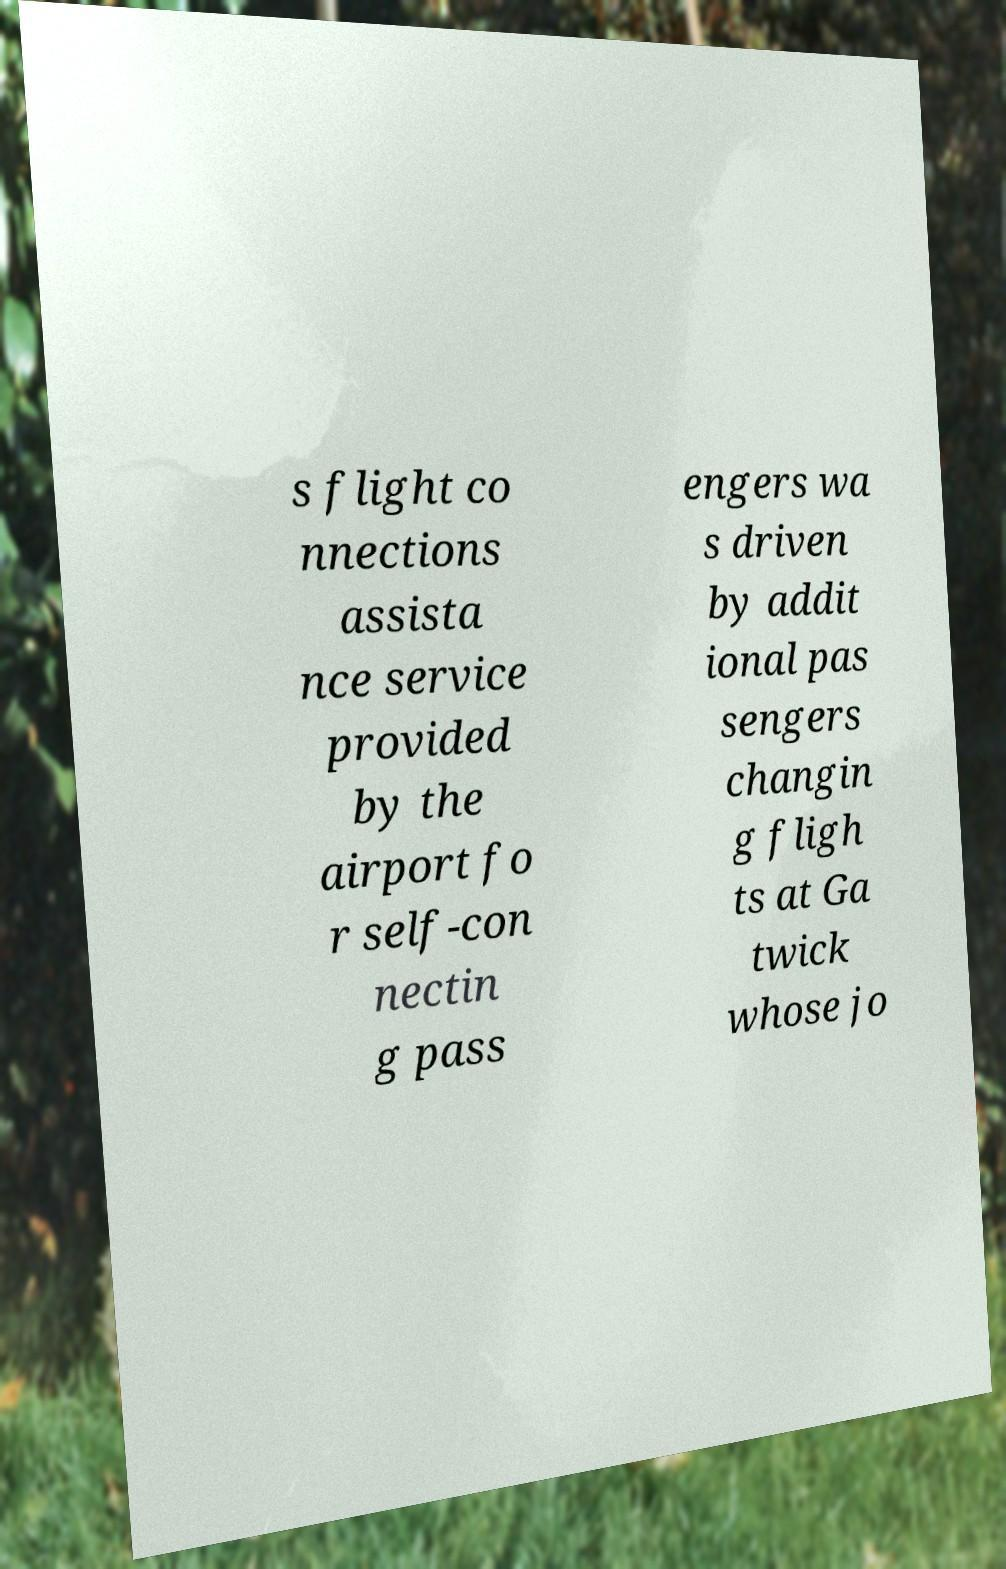Can you read and provide the text displayed in the image?This photo seems to have some interesting text. Can you extract and type it out for me? s flight co nnections assista nce service provided by the airport fo r self-con nectin g pass engers wa s driven by addit ional pas sengers changin g fligh ts at Ga twick whose jo 